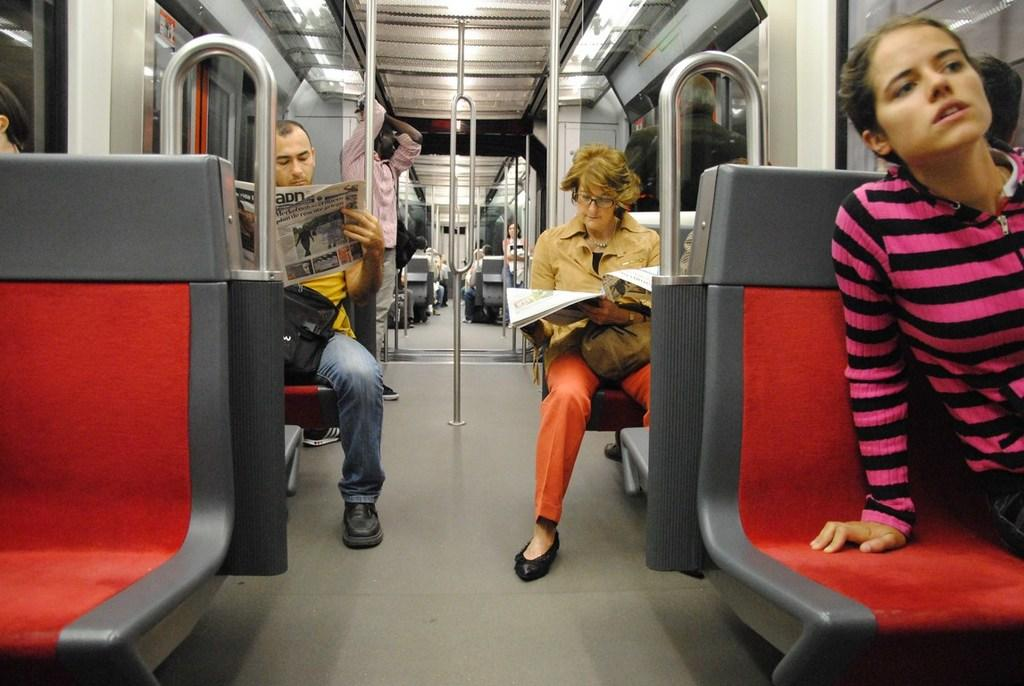What is the main activity of the people in the image? The main activity of the people in the image is sitting on the train. Can you describe the position of one person in the image? One person is standing in the image. What are two people doing in the image? Two persons are reading newspapers in the image. What can be seen on the top of the train in the image? There are lights visible on the top of the train in the image. What type of jar is being used to catch the tears of the person who is crying in the image? There is no person crying in the image, and therefore no jar is being used to catch tears. 